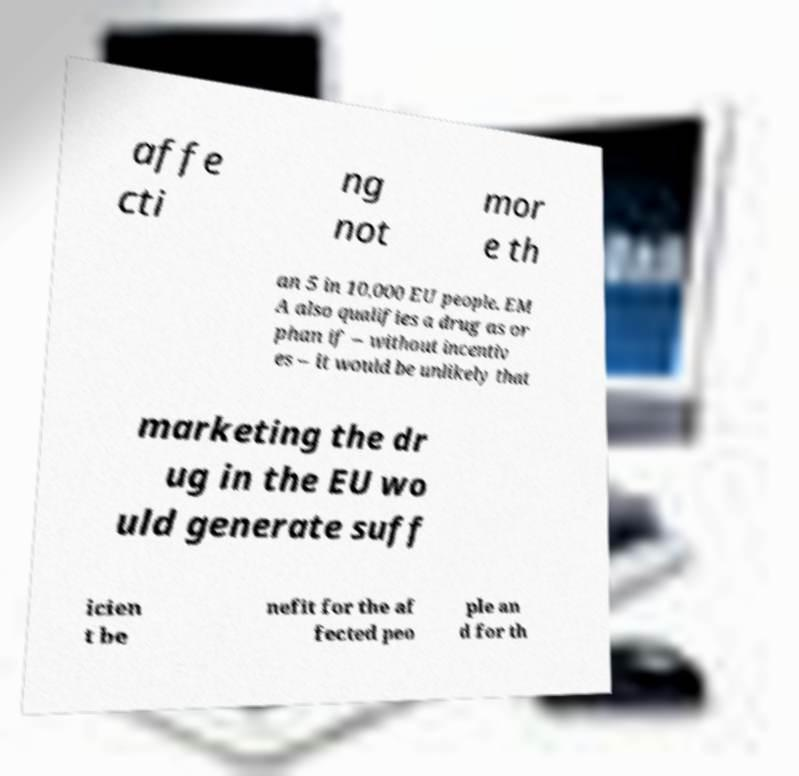Could you assist in decoding the text presented in this image and type it out clearly? affe cti ng not mor e th an 5 in 10,000 EU people. EM A also qualifies a drug as or phan if – without incentiv es – it would be unlikely that marketing the dr ug in the EU wo uld generate suff icien t be nefit for the af fected peo ple an d for th 